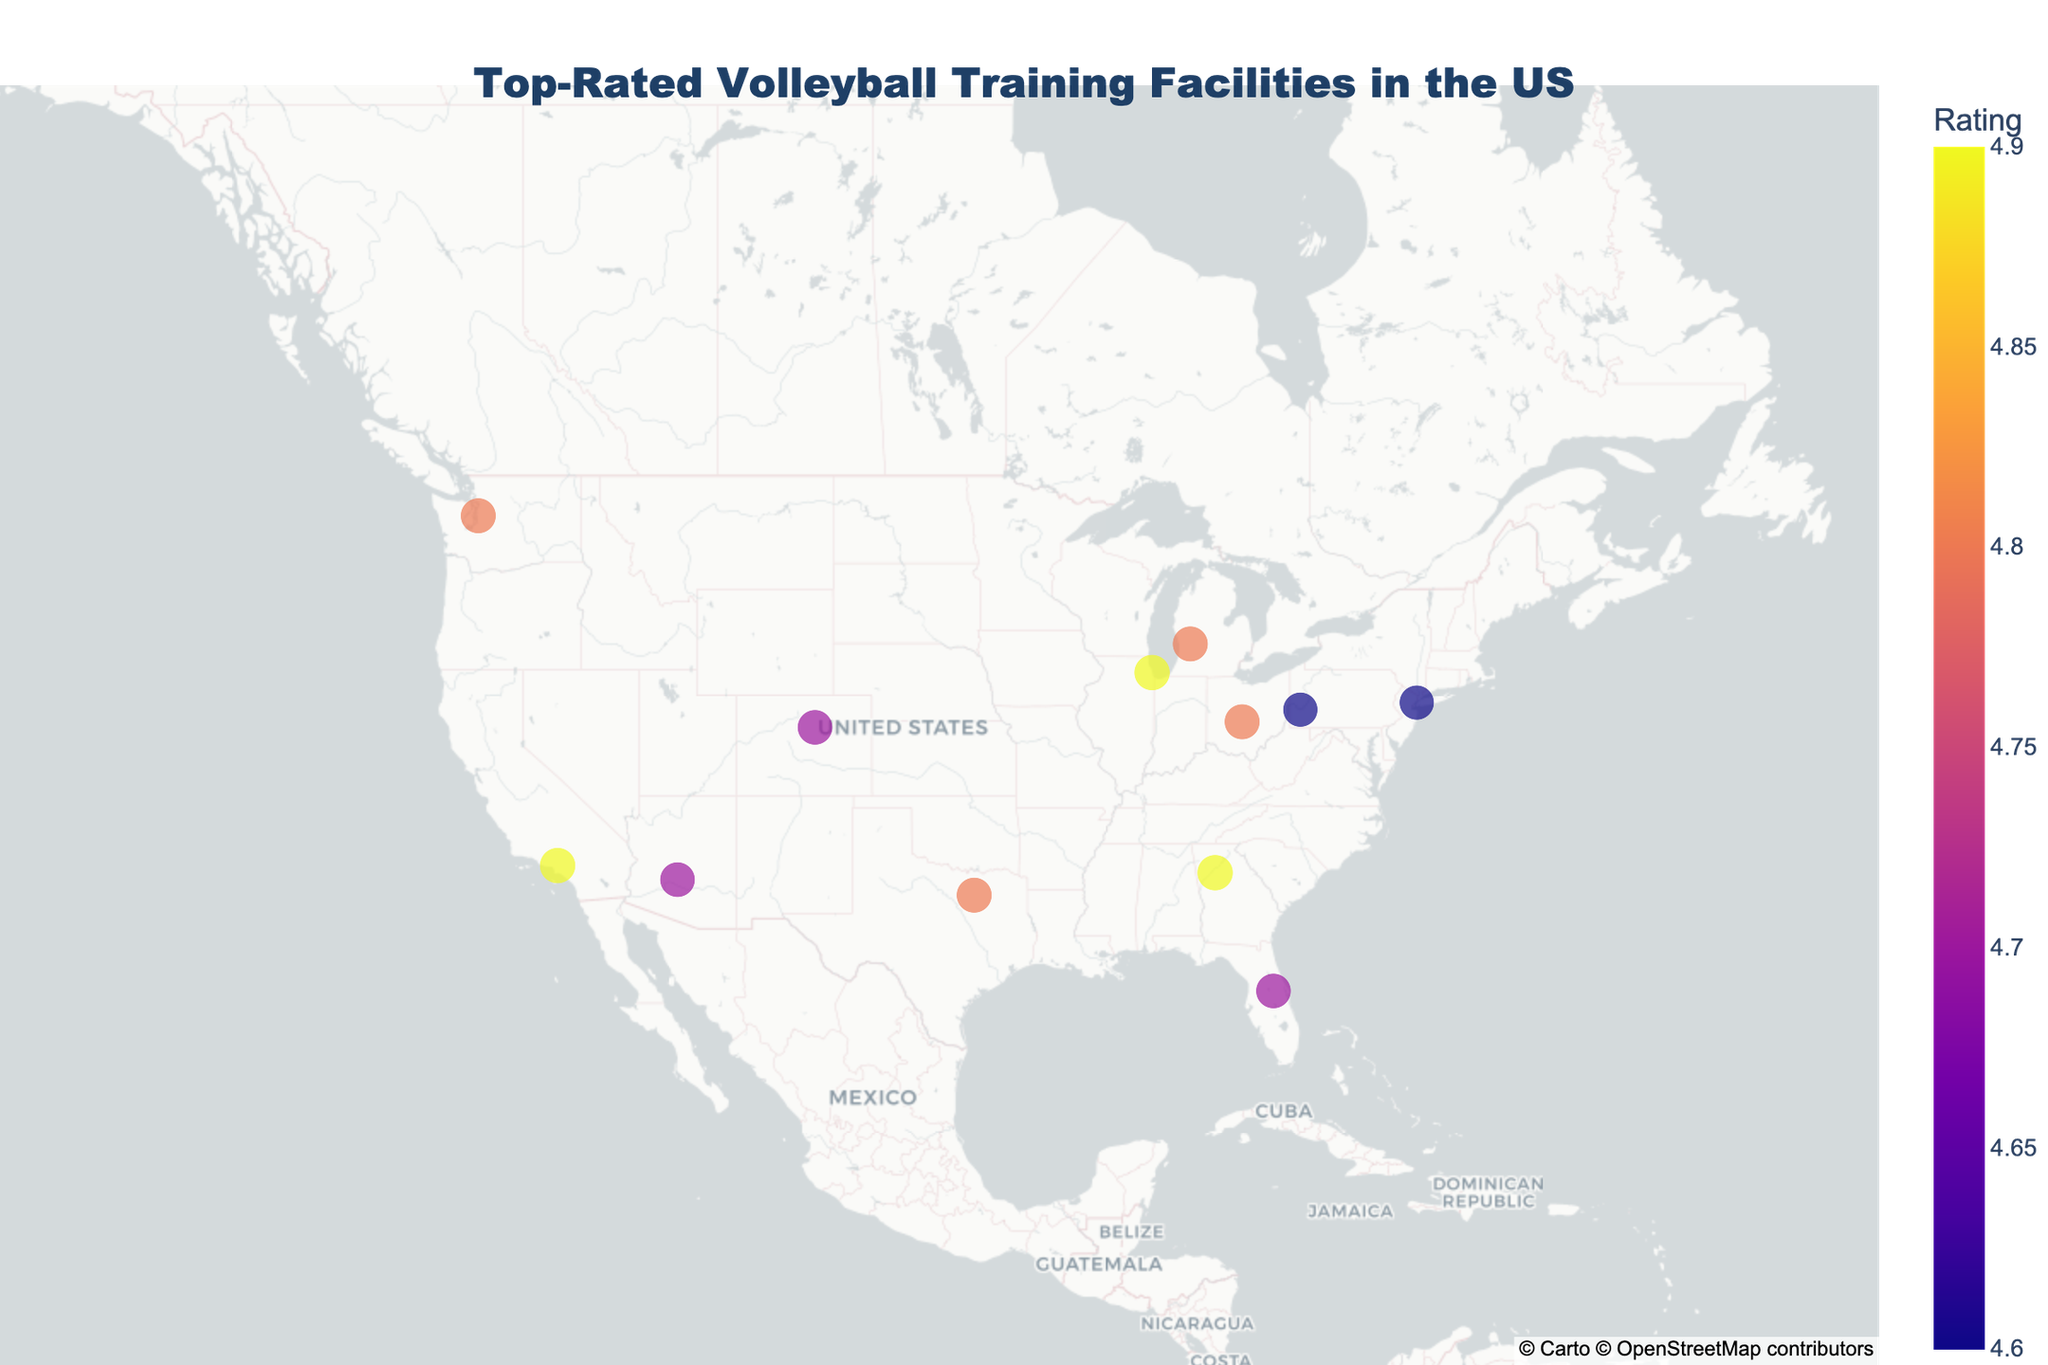What is the title of the figure? The title of the figure is usually shown at the top and specifies what the plot is about. Looking at the figure, the main title reads "Top-Rated Volleyball Training Facilities in the US".
Answer: Top-Rated Volleyball Training Facilities in the US Which city in California is represented on the map? Identify the state of California on the map and then locate the marked city within it. The figure shows Los Angeles, California.
Answer: Los Angeles How many facilities have a rating of 4.8 or higher? To answer this, count the number of data points that have a rating of 4.8 or higher based on the color or size indicating the rating. There are 7 such facilities: Dallas, Columbus, Seattle, Grand Rapids, Los Angeles, Chicago, and Atlanta.
Answer: 7 Which states have more than one training facility listed? Examine the list of facilities and their corresponding states. Each state in the figure has only one facility listed, so no states have more than one facility.
Answer: None What color represents the highest-rated facility on the map? The highest-rated facility should be indicated by the maximum color intensity on the scale used. Look for the most vibrant color on the map, which represents the highest rating. This color is part of the Plasma color scale, often a bright yellow or orange.
Answer: Bright yellow/orange Which city has the lowest-rated training facility, and what is its rating? Identify the city marked with the lowest color intensity corresponding to the lowest rating on the map. New York City has the lowest-rated training facility, with a rating of 4.6.
Answer: New York City, 4.6 What is the geographic center of the map based on latitude and longitude coordinates? The center of the map is specified in the explanation of the figure settings. It states that the map is centered at a latitude of 39.8283 and a longitude of -98.5795.
Answer: 39.8283, -98.5795 Which pair of cities in the list have the same rating, and what is the rating? Compare the ratings of each city and match those with identical ratings. Columbus (Ohio) and Grand Rapids (Michigan) both have a rating of 4.8.
Answer: Columbus and Grand Rapids, 4.8 How does the rating of the training facility in Seattle compare to that in Phoenix? Look at the ratings of the facilities in Seattle and Phoenix on the map. Seattle's rating is 4.8, and Phoenix's rating is 4.7. Hence, Seattle's rating is higher than Phoenix's rating.
Answer: Seattle's rating is higher What is the average rating of all the facilities listed on the map? Sum all the ratings and divide by the number of facilities to find the average. Adding all the ratings: 4.9 + 4.8 + 4.7 + 4.9 + 4.6 + 4.8 + 4.7 + 4.8 + 4.6 + 4.7 + 4.8 + 4.9 = 57.6. There are 12 facilities, so the average rating is 57.6 / 12 = 4.8.
Answer: 4.8 